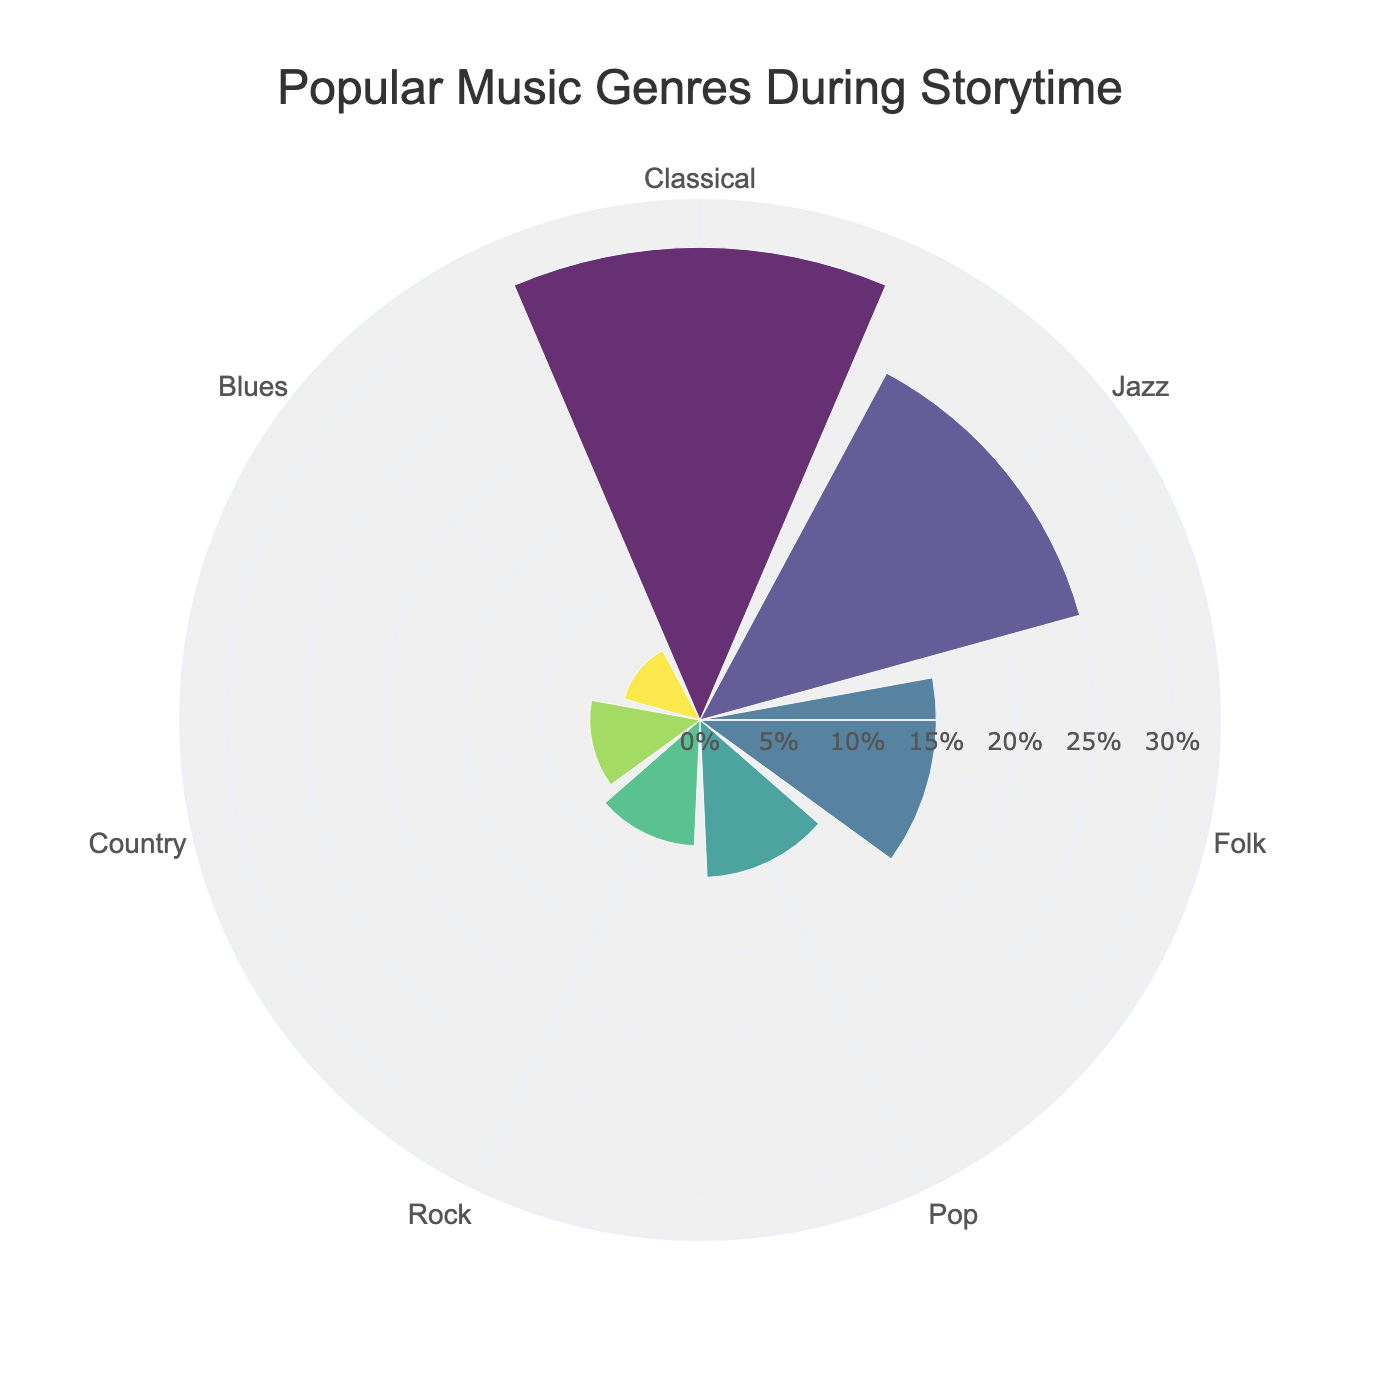Which genre has the highest preference percentage? Look for the genre with the largest value in the polar area chart. The sector with the highest percentage is Classical at 30%.
Answer: Classical What's the range of the radial axis? The radial axis range is indicated on the polar chart, and it extends up to the maximum value in the data. The maximum percentage is scaled up a bit for clarity. The range is from 0% to approximately 33%.
Answer: 0% to 33% How many music genres are displayed in the chart? Count the number of individual sectors in the polar area chart. There are 7 sectors, representing 7 music genres.
Answer: 7 Which genre has a preference percentage close to 10%? Identify the sector that is closest to the 10% mark in the chart. The sector for Pop has a 10% preference.
Answer: Pop What is the combined preference percentage of Rock and Country? Add the preference percentages of Rock and Country. Rock is 8% and Country is 7%, so 8% + 7% = 15%.
Answer: 15% Is the percentage preference for Blues less than that for Jazz? Compare the sectors representing Blues and Jazz. Blues has a 5% preference, and Jazz has a 25% preference. Therefore, Blues is less than Jazz.
Answer: Yes Which genre has the smallest preference percentage? Look for the smallest sector in the polar area chart. The genre with the smallest preference is Blues at 5%.
Answer: Blues How does the preference for Folk compare to that of Pop? Compare the values of Folk and Pop. Folk has a 15% preference, while Pop has a 10% preference. So, Folk is higher than Pop.
Answer: Folk is higher What is the average preference percentage of the three most preferred genres? Add the percentages of the top three genres and divide by three. Classical (30%) + Jazz (25%) + Folk (15%) = 70%. The average is 70% / 3 = 23.33%.
Answer: 23.33% What is the total preference percentage of all genres combined? Sum all the percentages together: 30% (Classical) + 25% (Jazz) + 15% (Folk) + 10% (Pop) + 8% (Rock) + 7% (Country) + 5% (Blues) = 100%.
Answer: 100% 